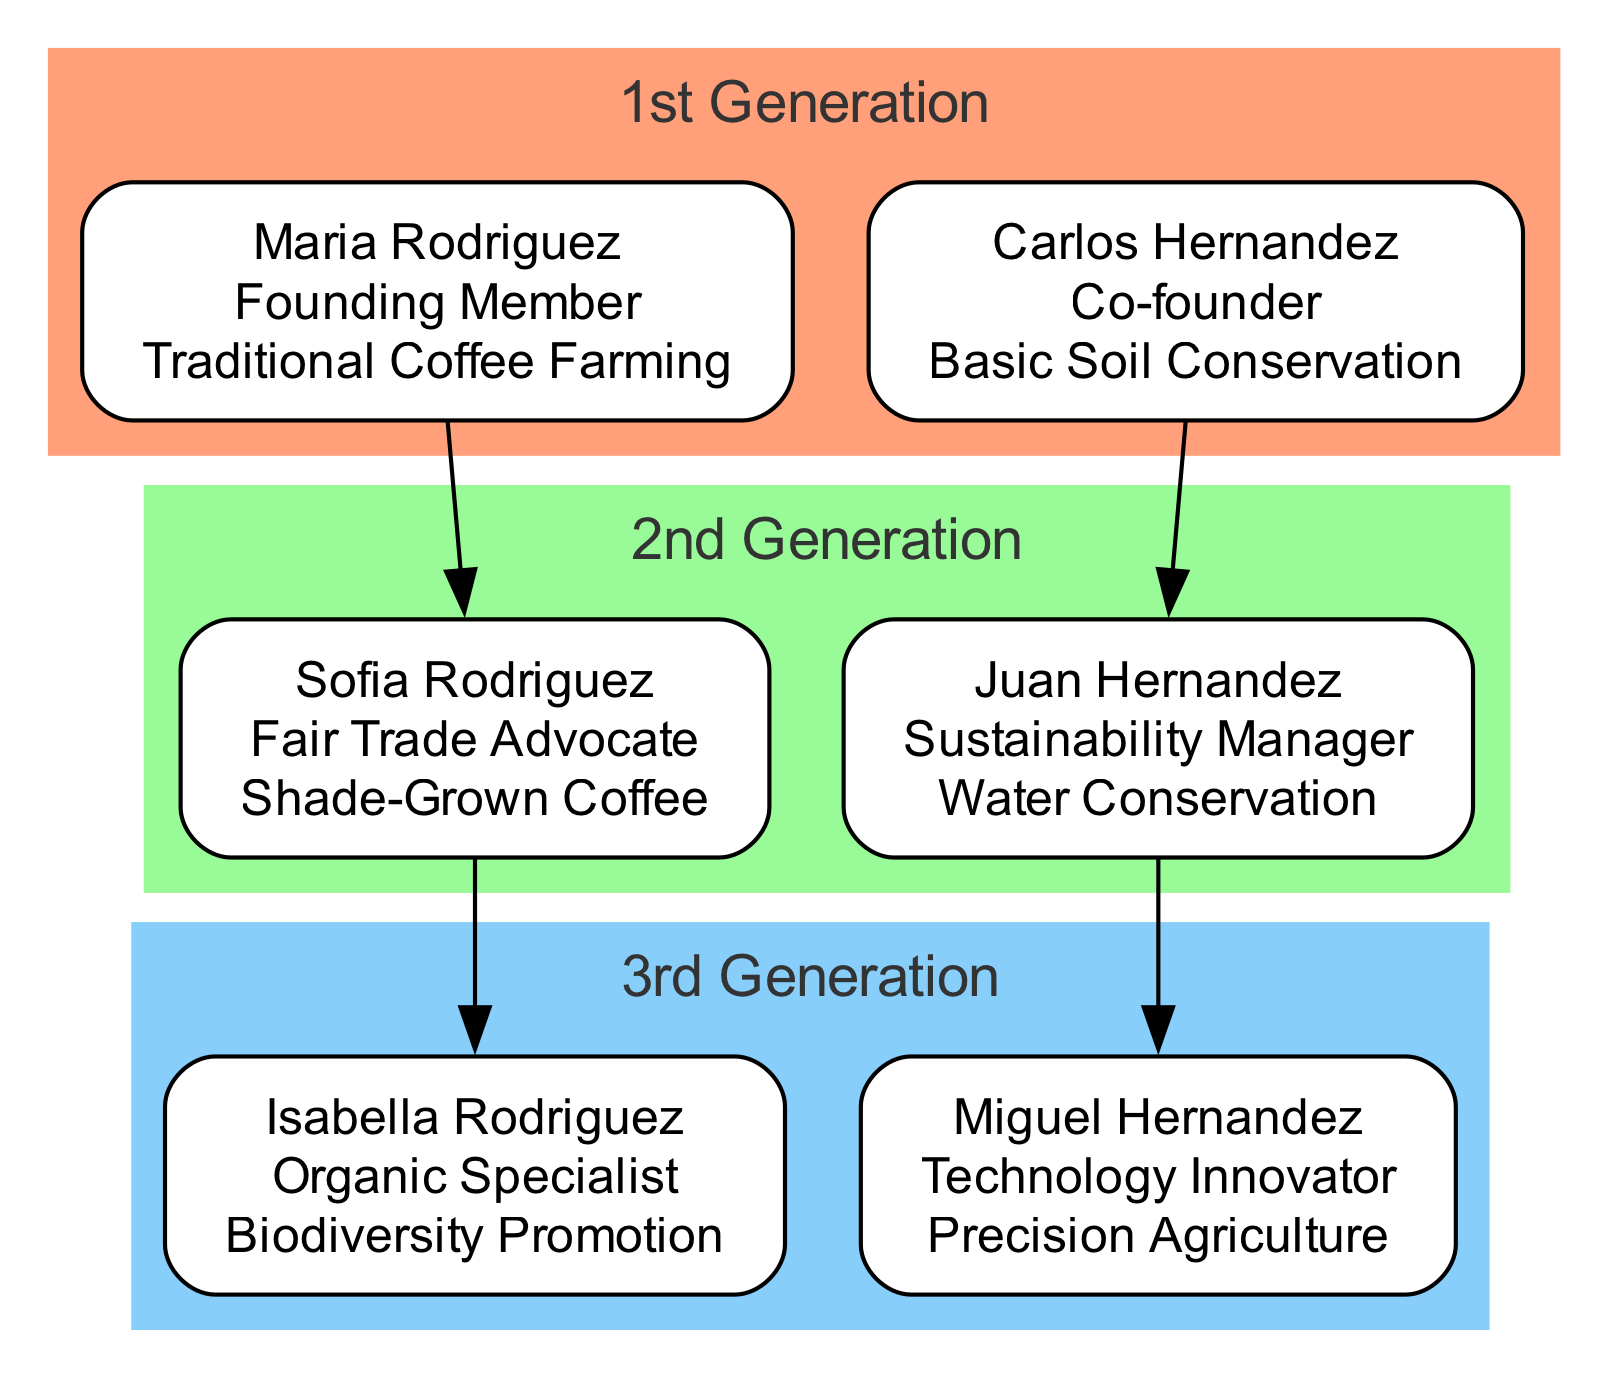What is the practice of Maria Rodriguez? Maria Rodriguez is labeled in the diagram as a "Founding Member" who practices "Traditional Coffee Farming".
Answer: Traditional Coffee Farming Who is the Sustainability Manager in the 2nd Generation? The diagram indicates that the "Sustainability Manager" position is held by Juan Hernandez in the 2nd Generation.
Answer: Juan Hernandez How many generations are represented in the diagram? The diagram contains three distinct generations: 1st Generation, 2nd Generation, and 3rd Generation, which sum to three generations in total.
Answer: 3 What farming practice is associated with Isabella Rodriguez? According to the diagram, Isabella Rodriguez is listed as an "Organic Specialist" who promotes "Biodiversity".
Answer: Biodiversity Promotion Which member from the 3rd Generation is involved in innovative technology? The diagram indicates that Miguel Hernandez is the member from the 3rd Generation identified as a "Technology Innovator".
Answer: Technology Innovator What is the direct relationship between Carlos Hernandez and Juan Hernandez? In the diagram, Carlos Hernandez is depicted as the father of Juan Hernandez, connecting the 1st Generation to the 2nd Generation.
Answer: Father Which generation first introduced Shade-Grown Coffee? The diagram shows that Shade-Grown Coffee was introduced in the 2nd Generation, specifically by Sofia Rodriguez.
Answer: 2nd Generation What color represents the 1st Generation in the diagram? The 1st Generation is represented in a light orange color (#FFA07A) as indicated in the color scheme of the diagram.
Answer: Light Orange Which practice evolved from Basic Soil Conservation? The progression from Basic Soil Conservation to improved practices is evident in the evolution from Carlos Hernandez in the 1st Generation to Juan Hernandez's "Water Conservation" in the 2nd Generation.
Answer: Water Conservation 